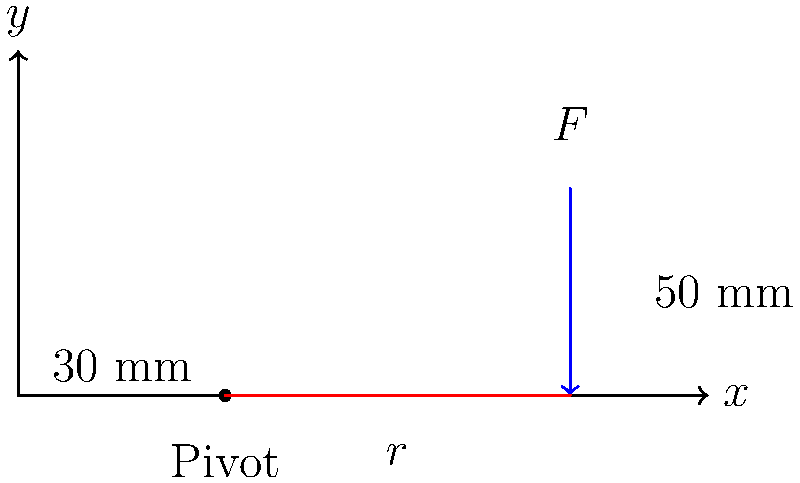In the context of biomechanics, consider a simplified model of a muscle-joint system represented by the lever diagram above. The muscle force $F$ acts vertically at a distance of 50 mm from the left end of the lever, while the pivot point is located 30 mm from the left end. Calculate the moment arm $r$ of the muscle force about the pivot point. To solve this problem, we'll follow these steps:

1. Understand the concept: The moment arm is the perpendicular distance from the line of action of a force to the axis of rotation (pivot point).

2. Analyze the diagram: 
   - The pivot point is 30 mm from the left end of the lever.
   - The force F is applied 50 mm from the left end of the lever.

3. Calculate the moment arm:
   - The moment arm is the horizontal distance between the pivot point and the point of force application.
   - Moment arm $r$ = Distance of force application - Distance of pivot point
   - $r = 50 \text{ mm} - 30 \text{ mm}$
   - $r = 20 \text{ mm}$

4. Convert to meters (SI unit):
   - $r = 20 \text{ mm} \times \frac{1 \text{ m}}{1000 \text{ mm}} = 0.02 \text{ m}$

Therefore, the moment arm of the muscle force about the pivot point is 0.02 m or 20 mm.
Answer: 0.02 m 